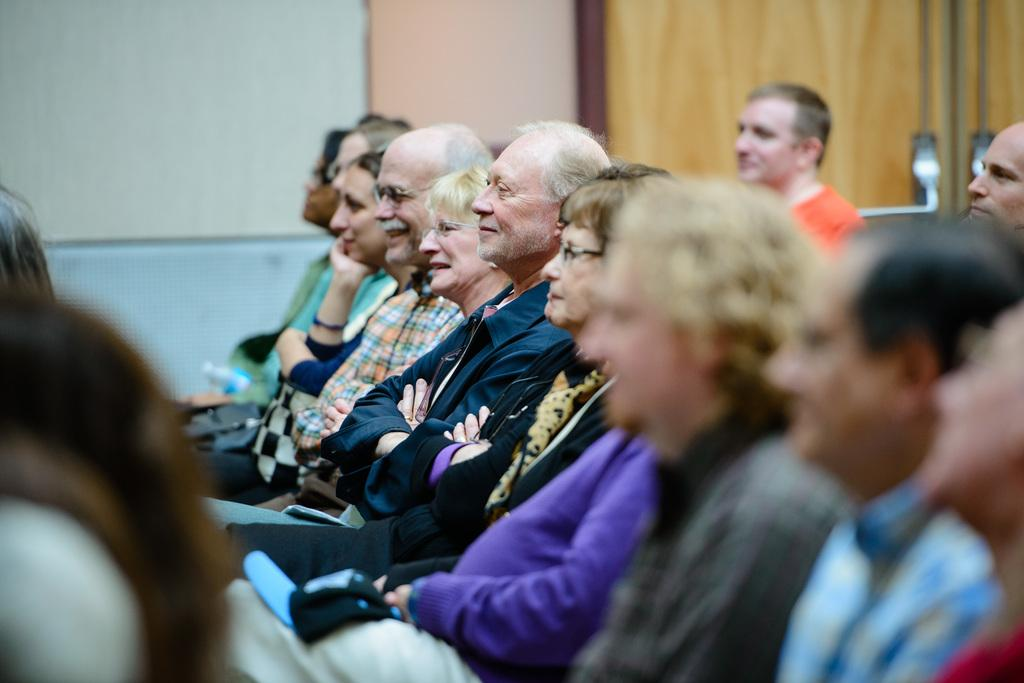What are the people in the image doing? The people in the image are sitting. What object can be seen near the people? There is a water bottle in the image. What can be seen in the background of the image? There is a wall in the background of the image. What word is the judge saying in the image? There is no judge present in the image, and therefore no words can be attributed to a judge. 